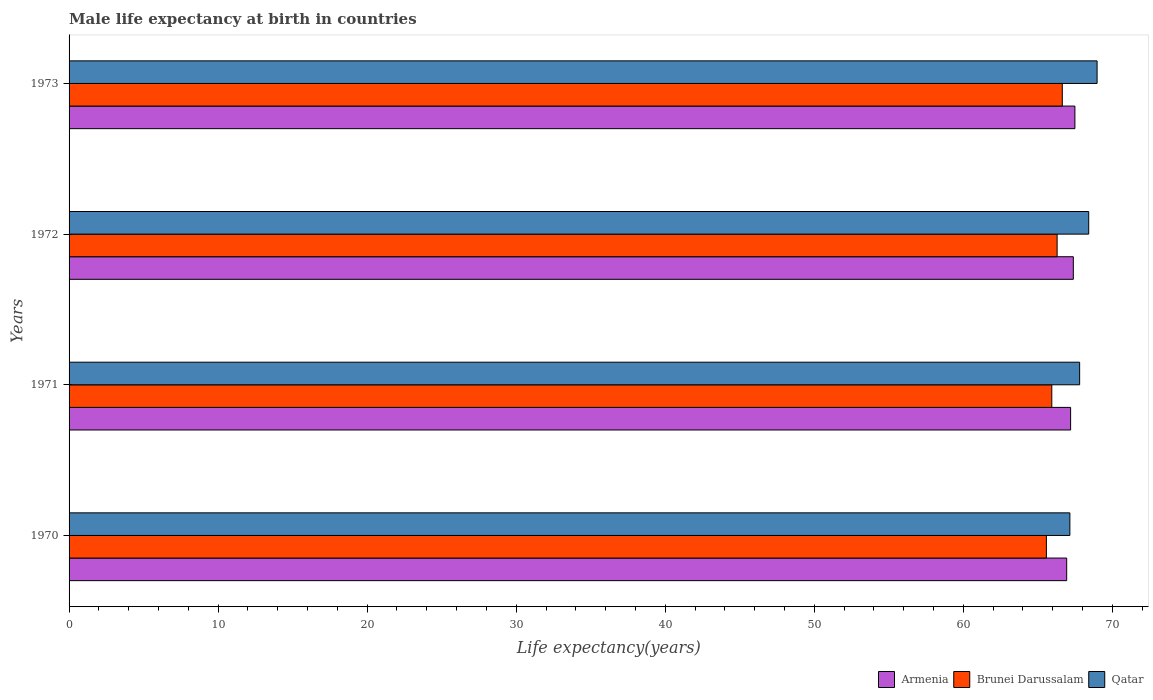Are the number of bars per tick equal to the number of legend labels?
Provide a short and direct response. Yes. Are the number of bars on each tick of the Y-axis equal?
Your answer should be very brief. Yes. How many bars are there on the 2nd tick from the top?
Offer a very short reply. 3. How many bars are there on the 1st tick from the bottom?
Offer a terse response. 3. In how many cases, is the number of bars for a given year not equal to the number of legend labels?
Provide a succinct answer. 0. What is the male life expectancy at birth in Qatar in 1973?
Provide a short and direct response. 68.97. Across all years, what is the maximum male life expectancy at birth in Brunei Darussalam?
Give a very brief answer. 66.64. Across all years, what is the minimum male life expectancy at birth in Qatar?
Your answer should be very brief. 67.15. In which year was the male life expectancy at birth in Brunei Darussalam minimum?
Provide a succinct answer. 1970. What is the total male life expectancy at birth in Qatar in the graph?
Provide a short and direct response. 272.34. What is the difference between the male life expectancy at birth in Qatar in 1970 and that in 1973?
Make the answer very short. -1.83. What is the difference between the male life expectancy at birth in Brunei Darussalam in 1971 and the male life expectancy at birth in Armenia in 1973?
Make the answer very short. -1.55. What is the average male life expectancy at birth in Brunei Darussalam per year?
Ensure brevity in your answer.  66.11. In the year 1970, what is the difference between the male life expectancy at birth in Armenia and male life expectancy at birth in Brunei Darussalam?
Offer a terse response. 1.36. What is the ratio of the male life expectancy at birth in Qatar in 1972 to that in 1973?
Your answer should be compact. 0.99. Is the male life expectancy at birth in Brunei Darussalam in 1971 less than that in 1972?
Keep it short and to the point. Yes. Is the difference between the male life expectancy at birth in Armenia in 1970 and 1971 greater than the difference between the male life expectancy at birth in Brunei Darussalam in 1970 and 1971?
Provide a succinct answer. Yes. What is the difference between the highest and the second highest male life expectancy at birth in Brunei Darussalam?
Offer a terse response. 0.35. What is the difference between the highest and the lowest male life expectancy at birth in Qatar?
Keep it short and to the point. 1.83. In how many years, is the male life expectancy at birth in Brunei Darussalam greater than the average male life expectancy at birth in Brunei Darussalam taken over all years?
Provide a short and direct response. 2. What does the 3rd bar from the top in 1970 represents?
Your answer should be very brief. Armenia. What does the 3rd bar from the bottom in 1971 represents?
Provide a succinct answer. Qatar. Is it the case that in every year, the sum of the male life expectancy at birth in Qatar and male life expectancy at birth in Armenia is greater than the male life expectancy at birth in Brunei Darussalam?
Your answer should be very brief. Yes. How many bars are there?
Your response must be concise. 12. How many years are there in the graph?
Your response must be concise. 4. Does the graph contain any zero values?
Your answer should be very brief. No. Does the graph contain grids?
Your response must be concise. No. How many legend labels are there?
Keep it short and to the point. 3. What is the title of the graph?
Your answer should be very brief. Male life expectancy at birth in countries. What is the label or title of the X-axis?
Offer a terse response. Life expectancy(years). What is the Life expectancy(years) in Armenia in 1970?
Your response must be concise. 66.94. What is the Life expectancy(years) of Brunei Darussalam in 1970?
Make the answer very short. 65.57. What is the Life expectancy(years) in Qatar in 1970?
Provide a succinct answer. 67.15. What is the Life expectancy(years) in Armenia in 1971?
Offer a terse response. 67.2. What is the Life expectancy(years) of Brunei Darussalam in 1971?
Your response must be concise. 65.94. What is the Life expectancy(years) in Qatar in 1971?
Your answer should be compact. 67.8. What is the Life expectancy(years) of Armenia in 1972?
Provide a short and direct response. 67.38. What is the Life expectancy(years) of Brunei Darussalam in 1972?
Make the answer very short. 66.29. What is the Life expectancy(years) of Qatar in 1972?
Keep it short and to the point. 68.41. What is the Life expectancy(years) of Armenia in 1973?
Give a very brief answer. 67.49. What is the Life expectancy(years) of Brunei Darussalam in 1973?
Keep it short and to the point. 66.64. What is the Life expectancy(years) in Qatar in 1973?
Offer a very short reply. 68.97. Across all years, what is the maximum Life expectancy(years) in Armenia?
Provide a short and direct response. 67.49. Across all years, what is the maximum Life expectancy(years) of Brunei Darussalam?
Offer a very short reply. 66.64. Across all years, what is the maximum Life expectancy(years) in Qatar?
Offer a very short reply. 68.97. Across all years, what is the minimum Life expectancy(years) in Armenia?
Provide a short and direct response. 66.94. Across all years, what is the minimum Life expectancy(years) in Brunei Darussalam?
Ensure brevity in your answer.  65.57. Across all years, what is the minimum Life expectancy(years) in Qatar?
Give a very brief answer. 67.15. What is the total Life expectancy(years) of Armenia in the graph?
Give a very brief answer. 269. What is the total Life expectancy(years) of Brunei Darussalam in the graph?
Keep it short and to the point. 264.44. What is the total Life expectancy(years) in Qatar in the graph?
Offer a very short reply. 272.34. What is the difference between the Life expectancy(years) in Armenia in 1970 and that in 1971?
Your answer should be compact. -0.26. What is the difference between the Life expectancy(years) in Brunei Darussalam in 1970 and that in 1971?
Offer a very short reply. -0.36. What is the difference between the Life expectancy(years) in Qatar in 1970 and that in 1971?
Make the answer very short. -0.66. What is the difference between the Life expectancy(years) in Armenia in 1970 and that in 1972?
Give a very brief answer. -0.45. What is the difference between the Life expectancy(years) in Brunei Darussalam in 1970 and that in 1972?
Offer a very short reply. -0.72. What is the difference between the Life expectancy(years) of Qatar in 1970 and that in 1972?
Offer a terse response. -1.26. What is the difference between the Life expectancy(years) of Armenia in 1970 and that in 1973?
Your response must be concise. -0.55. What is the difference between the Life expectancy(years) of Brunei Darussalam in 1970 and that in 1973?
Provide a succinct answer. -1.07. What is the difference between the Life expectancy(years) in Qatar in 1970 and that in 1973?
Keep it short and to the point. -1.83. What is the difference between the Life expectancy(years) in Armenia in 1971 and that in 1972?
Ensure brevity in your answer.  -0.18. What is the difference between the Life expectancy(years) in Brunei Darussalam in 1971 and that in 1972?
Your response must be concise. -0.36. What is the difference between the Life expectancy(years) of Qatar in 1971 and that in 1972?
Provide a succinct answer. -0.61. What is the difference between the Life expectancy(years) of Armenia in 1971 and that in 1973?
Your response must be concise. -0.29. What is the difference between the Life expectancy(years) in Brunei Darussalam in 1971 and that in 1973?
Provide a succinct answer. -0.7. What is the difference between the Life expectancy(years) in Qatar in 1971 and that in 1973?
Your response must be concise. -1.17. What is the difference between the Life expectancy(years) of Armenia in 1972 and that in 1973?
Provide a succinct answer. -0.1. What is the difference between the Life expectancy(years) in Brunei Darussalam in 1972 and that in 1973?
Offer a terse response. -0.35. What is the difference between the Life expectancy(years) in Qatar in 1972 and that in 1973?
Provide a succinct answer. -0.56. What is the difference between the Life expectancy(years) of Armenia in 1970 and the Life expectancy(years) of Qatar in 1971?
Ensure brevity in your answer.  -0.87. What is the difference between the Life expectancy(years) in Brunei Darussalam in 1970 and the Life expectancy(years) in Qatar in 1971?
Make the answer very short. -2.23. What is the difference between the Life expectancy(years) in Armenia in 1970 and the Life expectancy(years) in Brunei Darussalam in 1972?
Provide a succinct answer. 0.64. What is the difference between the Life expectancy(years) of Armenia in 1970 and the Life expectancy(years) of Qatar in 1972?
Offer a terse response. -1.48. What is the difference between the Life expectancy(years) in Brunei Darussalam in 1970 and the Life expectancy(years) in Qatar in 1972?
Your answer should be compact. -2.84. What is the difference between the Life expectancy(years) of Armenia in 1970 and the Life expectancy(years) of Brunei Darussalam in 1973?
Your response must be concise. 0.29. What is the difference between the Life expectancy(years) of Armenia in 1970 and the Life expectancy(years) of Qatar in 1973?
Make the answer very short. -2.04. What is the difference between the Life expectancy(years) of Brunei Darussalam in 1970 and the Life expectancy(years) of Qatar in 1973?
Provide a short and direct response. -3.4. What is the difference between the Life expectancy(years) of Armenia in 1971 and the Life expectancy(years) of Brunei Darussalam in 1972?
Your response must be concise. 0.91. What is the difference between the Life expectancy(years) in Armenia in 1971 and the Life expectancy(years) in Qatar in 1972?
Your answer should be very brief. -1.22. What is the difference between the Life expectancy(years) of Brunei Darussalam in 1971 and the Life expectancy(years) of Qatar in 1972?
Keep it short and to the point. -2.48. What is the difference between the Life expectancy(years) in Armenia in 1971 and the Life expectancy(years) in Brunei Darussalam in 1973?
Provide a succinct answer. 0.56. What is the difference between the Life expectancy(years) in Armenia in 1971 and the Life expectancy(years) in Qatar in 1973?
Keep it short and to the point. -1.78. What is the difference between the Life expectancy(years) of Brunei Darussalam in 1971 and the Life expectancy(years) of Qatar in 1973?
Provide a succinct answer. -3.04. What is the difference between the Life expectancy(years) of Armenia in 1972 and the Life expectancy(years) of Brunei Darussalam in 1973?
Ensure brevity in your answer.  0.74. What is the difference between the Life expectancy(years) of Armenia in 1972 and the Life expectancy(years) of Qatar in 1973?
Offer a terse response. -1.59. What is the difference between the Life expectancy(years) of Brunei Darussalam in 1972 and the Life expectancy(years) of Qatar in 1973?
Ensure brevity in your answer.  -2.68. What is the average Life expectancy(years) in Armenia per year?
Offer a terse response. 67.25. What is the average Life expectancy(years) in Brunei Darussalam per year?
Provide a short and direct response. 66.11. What is the average Life expectancy(years) in Qatar per year?
Keep it short and to the point. 68.09. In the year 1970, what is the difference between the Life expectancy(years) in Armenia and Life expectancy(years) in Brunei Darussalam?
Give a very brief answer. 1.36. In the year 1970, what is the difference between the Life expectancy(years) in Armenia and Life expectancy(years) in Qatar?
Make the answer very short. -0.21. In the year 1970, what is the difference between the Life expectancy(years) of Brunei Darussalam and Life expectancy(years) of Qatar?
Offer a very short reply. -1.58. In the year 1971, what is the difference between the Life expectancy(years) in Armenia and Life expectancy(years) in Brunei Darussalam?
Ensure brevity in your answer.  1.26. In the year 1971, what is the difference between the Life expectancy(years) of Armenia and Life expectancy(years) of Qatar?
Provide a short and direct response. -0.61. In the year 1971, what is the difference between the Life expectancy(years) in Brunei Darussalam and Life expectancy(years) in Qatar?
Ensure brevity in your answer.  -1.87. In the year 1972, what is the difference between the Life expectancy(years) in Armenia and Life expectancy(years) in Brunei Darussalam?
Provide a succinct answer. 1.09. In the year 1972, what is the difference between the Life expectancy(years) of Armenia and Life expectancy(years) of Qatar?
Provide a short and direct response. -1.03. In the year 1972, what is the difference between the Life expectancy(years) of Brunei Darussalam and Life expectancy(years) of Qatar?
Your answer should be very brief. -2.12. In the year 1973, what is the difference between the Life expectancy(years) in Armenia and Life expectancy(years) in Brunei Darussalam?
Your answer should be very brief. 0.84. In the year 1973, what is the difference between the Life expectancy(years) in Armenia and Life expectancy(years) in Qatar?
Ensure brevity in your answer.  -1.49. In the year 1973, what is the difference between the Life expectancy(years) in Brunei Darussalam and Life expectancy(years) in Qatar?
Provide a short and direct response. -2.33. What is the ratio of the Life expectancy(years) of Qatar in 1970 to that in 1971?
Offer a terse response. 0.99. What is the ratio of the Life expectancy(years) in Brunei Darussalam in 1970 to that in 1972?
Your answer should be very brief. 0.99. What is the ratio of the Life expectancy(years) in Qatar in 1970 to that in 1972?
Provide a short and direct response. 0.98. What is the ratio of the Life expectancy(years) of Qatar in 1970 to that in 1973?
Keep it short and to the point. 0.97. What is the ratio of the Life expectancy(years) of Brunei Darussalam in 1971 to that in 1973?
Your response must be concise. 0.99. What is the ratio of the Life expectancy(years) in Qatar in 1971 to that in 1973?
Ensure brevity in your answer.  0.98. What is the ratio of the Life expectancy(years) in Brunei Darussalam in 1972 to that in 1973?
Provide a short and direct response. 0.99. What is the difference between the highest and the second highest Life expectancy(years) in Armenia?
Your answer should be very brief. 0.1. What is the difference between the highest and the second highest Life expectancy(years) of Brunei Darussalam?
Give a very brief answer. 0.35. What is the difference between the highest and the second highest Life expectancy(years) in Qatar?
Ensure brevity in your answer.  0.56. What is the difference between the highest and the lowest Life expectancy(years) in Armenia?
Ensure brevity in your answer.  0.55. What is the difference between the highest and the lowest Life expectancy(years) in Brunei Darussalam?
Keep it short and to the point. 1.07. What is the difference between the highest and the lowest Life expectancy(years) of Qatar?
Your response must be concise. 1.83. 